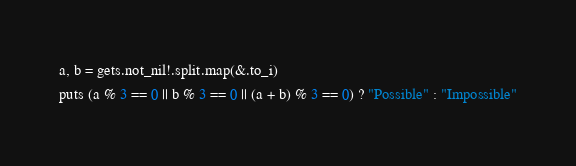<code> <loc_0><loc_0><loc_500><loc_500><_Crystal_>a, b = gets.not_nil!.split.map(&.to_i)
puts (a % 3 == 0 || b % 3 == 0 || (a + b) % 3 == 0) ? "Possible" : "Impossible"
</code> 